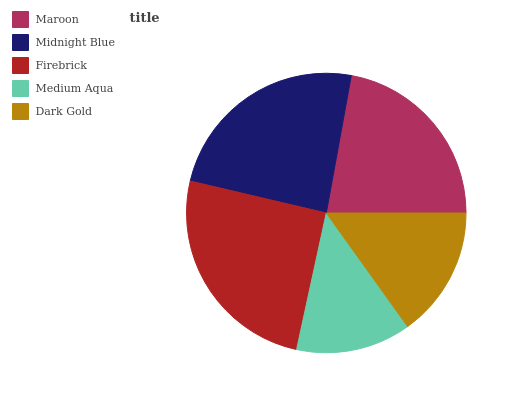Is Medium Aqua the minimum?
Answer yes or no. Yes. Is Firebrick the maximum?
Answer yes or no. Yes. Is Midnight Blue the minimum?
Answer yes or no. No. Is Midnight Blue the maximum?
Answer yes or no. No. Is Midnight Blue greater than Maroon?
Answer yes or no. Yes. Is Maroon less than Midnight Blue?
Answer yes or no. Yes. Is Maroon greater than Midnight Blue?
Answer yes or no. No. Is Midnight Blue less than Maroon?
Answer yes or no. No. Is Maroon the high median?
Answer yes or no. Yes. Is Maroon the low median?
Answer yes or no. Yes. Is Medium Aqua the high median?
Answer yes or no. No. Is Firebrick the low median?
Answer yes or no. No. 